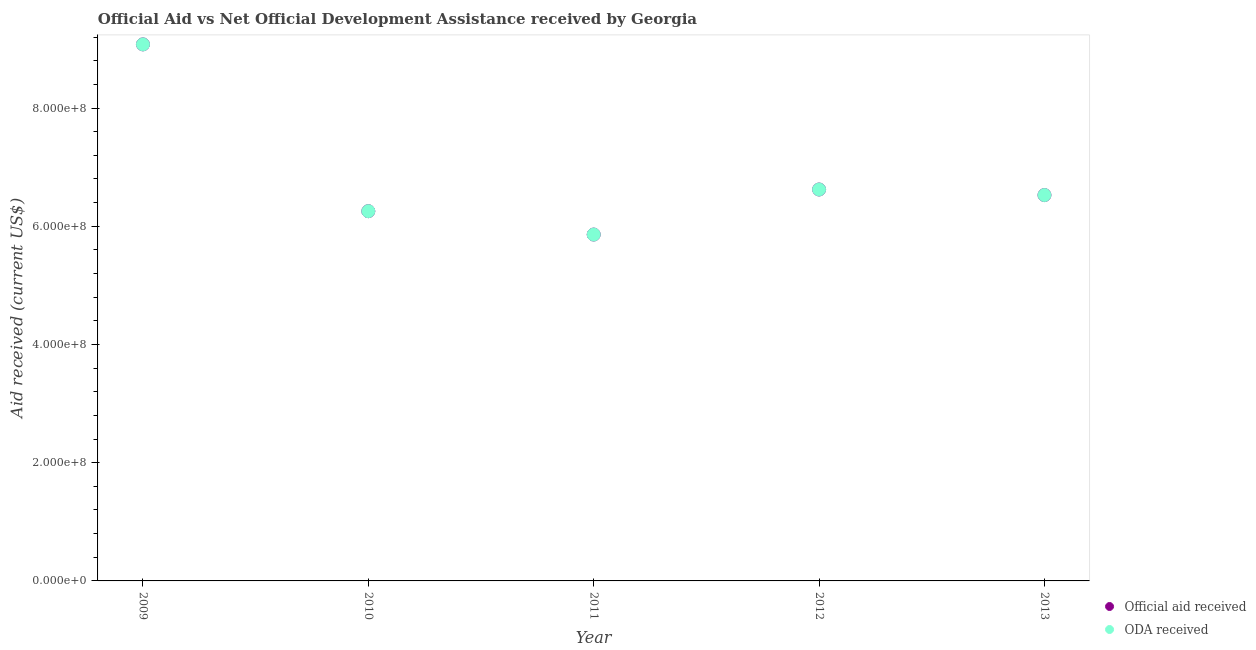How many different coloured dotlines are there?
Offer a very short reply. 2. What is the oda received in 2013?
Your response must be concise. 6.53e+08. Across all years, what is the maximum oda received?
Your answer should be very brief. 9.08e+08. Across all years, what is the minimum oda received?
Provide a succinct answer. 5.86e+08. In which year was the oda received minimum?
Give a very brief answer. 2011. What is the total oda received in the graph?
Your response must be concise. 3.43e+09. What is the difference between the official aid received in 2011 and that in 2013?
Provide a succinct answer. -6.68e+07. What is the difference between the official aid received in 2011 and the oda received in 2009?
Your answer should be compact. -3.22e+08. What is the average official aid received per year?
Offer a very short reply. 6.87e+08. In the year 2010, what is the difference between the official aid received and oda received?
Keep it short and to the point. 0. In how many years, is the oda received greater than 160000000 US$?
Keep it short and to the point. 5. What is the ratio of the official aid received in 2009 to that in 2012?
Provide a succinct answer. 1.37. What is the difference between the highest and the second highest official aid received?
Offer a terse response. 2.45e+08. What is the difference between the highest and the lowest official aid received?
Your answer should be compact. 3.22e+08. In how many years, is the oda received greater than the average oda received taken over all years?
Give a very brief answer. 1. Does the official aid received monotonically increase over the years?
Your answer should be very brief. No. Is the official aid received strictly greater than the oda received over the years?
Offer a terse response. No. How many dotlines are there?
Your answer should be very brief. 2. How many legend labels are there?
Offer a very short reply. 2. What is the title of the graph?
Your response must be concise. Official Aid vs Net Official Development Assistance received by Georgia . What is the label or title of the X-axis?
Give a very brief answer. Year. What is the label or title of the Y-axis?
Provide a succinct answer. Aid received (current US$). What is the Aid received (current US$) of Official aid received in 2009?
Offer a terse response. 9.08e+08. What is the Aid received (current US$) of ODA received in 2009?
Provide a short and direct response. 9.08e+08. What is the Aid received (current US$) in Official aid received in 2010?
Your answer should be compact. 6.26e+08. What is the Aid received (current US$) of ODA received in 2010?
Your answer should be very brief. 6.26e+08. What is the Aid received (current US$) in Official aid received in 2011?
Provide a short and direct response. 5.86e+08. What is the Aid received (current US$) in ODA received in 2011?
Provide a short and direct response. 5.86e+08. What is the Aid received (current US$) in Official aid received in 2012?
Make the answer very short. 6.62e+08. What is the Aid received (current US$) in ODA received in 2012?
Make the answer very short. 6.62e+08. What is the Aid received (current US$) of Official aid received in 2013?
Provide a succinct answer. 6.53e+08. What is the Aid received (current US$) in ODA received in 2013?
Make the answer very short. 6.53e+08. Across all years, what is the maximum Aid received (current US$) in Official aid received?
Offer a terse response. 9.08e+08. Across all years, what is the maximum Aid received (current US$) of ODA received?
Make the answer very short. 9.08e+08. Across all years, what is the minimum Aid received (current US$) in Official aid received?
Offer a very short reply. 5.86e+08. Across all years, what is the minimum Aid received (current US$) of ODA received?
Your answer should be compact. 5.86e+08. What is the total Aid received (current US$) of Official aid received in the graph?
Your answer should be compact. 3.43e+09. What is the total Aid received (current US$) in ODA received in the graph?
Keep it short and to the point. 3.43e+09. What is the difference between the Aid received (current US$) in Official aid received in 2009 and that in 2010?
Your answer should be compact. 2.82e+08. What is the difference between the Aid received (current US$) of ODA received in 2009 and that in 2010?
Ensure brevity in your answer.  2.82e+08. What is the difference between the Aid received (current US$) of Official aid received in 2009 and that in 2011?
Your answer should be very brief. 3.22e+08. What is the difference between the Aid received (current US$) in ODA received in 2009 and that in 2011?
Ensure brevity in your answer.  3.22e+08. What is the difference between the Aid received (current US$) in Official aid received in 2009 and that in 2012?
Your answer should be compact. 2.45e+08. What is the difference between the Aid received (current US$) of ODA received in 2009 and that in 2012?
Make the answer very short. 2.45e+08. What is the difference between the Aid received (current US$) of Official aid received in 2009 and that in 2013?
Keep it short and to the point. 2.55e+08. What is the difference between the Aid received (current US$) in ODA received in 2009 and that in 2013?
Ensure brevity in your answer.  2.55e+08. What is the difference between the Aid received (current US$) in Official aid received in 2010 and that in 2011?
Provide a succinct answer. 3.95e+07. What is the difference between the Aid received (current US$) of ODA received in 2010 and that in 2011?
Keep it short and to the point. 3.95e+07. What is the difference between the Aid received (current US$) in Official aid received in 2010 and that in 2012?
Keep it short and to the point. -3.67e+07. What is the difference between the Aid received (current US$) of ODA received in 2010 and that in 2012?
Provide a short and direct response. -3.67e+07. What is the difference between the Aid received (current US$) of Official aid received in 2010 and that in 2013?
Your answer should be compact. -2.73e+07. What is the difference between the Aid received (current US$) in ODA received in 2010 and that in 2013?
Keep it short and to the point. -2.73e+07. What is the difference between the Aid received (current US$) of Official aid received in 2011 and that in 2012?
Provide a succinct answer. -7.62e+07. What is the difference between the Aid received (current US$) in ODA received in 2011 and that in 2012?
Your response must be concise. -7.62e+07. What is the difference between the Aid received (current US$) in Official aid received in 2011 and that in 2013?
Keep it short and to the point. -6.68e+07. What is the difference between the Aid received (current US$) of ODA received in 2011 and that in 2013?
Your answer should be very brief. -6.68e+07. What is the difference between the Aid received (current US$) of Official aid received in 2012 and that in 2013?
Provide a short and direct response. 9.43e+06. What is the difference between the Aid received (current US$) of ODA received in 2012 and that in 2013?
Provide a succinct answer. 9.43e+06. What is the difference between the Aid received (current US$) in Official aid received in 2009 and the Aid received (current US$) in ODA received in 2010?
Make the answer very short. 2.82e+08. What is the difference between the Aid received (current US$) in Official aid received in 2009 and the Aid received (current US$) in ODA received in 2011?
Provide a short and direct response. 3.22e+08. What is the difference between the Aid received (current US$) of Official aid received in 2009 and the Aid received (current US$) of ODA received in 2012?
Provide a succinct answer. 2.45e+08. What is the difference between the Aid received (current US$) of Official aid received in 2009 and the Aid received (current US$) of ODA received in 2013?
Provide a succinct answer. 2.55e+08. What is the difference between the Aid received (current US$) in Official aid received in 2010 and the Aid received (current US$) in ODA received in 2011?
Your answer should be very brief. 3.95e+07. What is the difference between the Aid received (current US$) of Official aid received in 2010 and the Aid received (current US$) of ODA received in 2012?
Your response must be concise. -3.67e+07. What is the difference between the Aid received (current US$) in Official aid received in 2010 and the Aid received (current US$) in ODA received in 2013?
Your response must be concise. -2.73e+07. What is the difference between the Aid received (current US$) in Official aid received in 2011 and the Aid received (current US$) in ODA received in 2012?
Ensure brevity in your answer.  -7.62e+07. What is the difference between the Aid received (current US$) of Official aid received in 2011 and the Aid received (current US$) of ODA received in 2013?
Your answer should be compact. -6.68e+07. What is the difference between the Aid received (current US$) of Official aid received in 2012 and the Aid received (current US$) of ODA received in 2013?
Your answer should be very brief. 9.43e+06. What is the average Aid received (current US$) of Official aid received per year?
Provide a succinct answer. 6.87e+08. What is the average Aid received (current US$) of ODA received per year?
Make the answer very short. 6.87e+08. In the year 2010, what is the difference between the Aid received (current US$) in Official aid received and Aid received (current US$) in ODA received?
Your answer should be very brief. 0. In the year 2013, what is the difference between the Aid received (current US$) in Official aid received and Aid received (current US$) in ODA received?
Ensure brevity in your answer.  0. What is the ratio of the Aid received (current US$) of Official aid received in 2009 to that in 2010?
Your answer should be compact. 1.45. What is the ratio of the Aid received (current US$) in ODA received in 2009 to that in 2010?
Offer a very short reply. 1.45. What is the ratio of the Aid received (current US$) of Official aid received in 2009 to that in 2011?
Your answer should be compact. 1.55. What is the ratio of the Aid received (current US$) in ODA received in 2009 to that in 2011?
Provide a short and direct response. 1.55. What is the ratio of the Aid received (current US$) in Official aid received in 2009 to that in 2012?
Keep it short and to the point. 1.37. What is the ratio of the Aid received (current US$) in ODA received in 2009 to that in 2012?
Ensure brevity in your answer.  1.37. What is the ratio of the Aid received (current US$) in Official aid received in 2009 to that in 2013?
Give a very brief answer. 1.39. What is the ratio of the Aid received (current US$) of ODA received in 2009 to that in 2013?
Provide a succinct answer. 1.39. What is the ratio of the Aid received (current US$) in Official aid received in 2010 to that in 2011?
Provide a succinct answer. 1.07. What is the ratio of the Aid received (current US$) of ODA received in 2010 to that in 2011?
Provide a short and direct response. 1.07. What is the ratio of the Aid received (current US$) of Official aid received in 2010 to that in 2012?
Keep it short and to the point. 0.94. What is the ratio of the Aid received (current US$) of ODA received in 2010 to that in 2012?
Keep it short and to the point. 0.94. What is the ratio of the Aid received (current US$) of Official aid received in 2010 to that in 2013?
Your answer should be compact. 0.96. What is the ratio of the Aid received (current US$) of ODA received in 2010 to that in 2013?
Give a very brief answer. 0.96. What is the ratio of the Aid received (current US$) in Official aid received in 2011 to that in 2012?
Provide a succinct answer. 0.88. What is the ratio of the Aid received (current US$) in ODA received in 2011 to that in 2012?
Give a very brief answer. 0.88. What is the ratio of the Aid received (current US$) in Official aid received in 2011 to that in 2013?
Offer a very short reply. 0.9. What is the ratio of the Aid received (current US$) of ODA received in 2011 to that in 2013?
Your answer should be very brief. 0.9. What is the ratio of the Aid received (current US$) in Official aid received in 2012 to that in 2013?
Offer a terse response. 1.01. What is the ratio of the Aid received (current US$) in ODA received in 2012 to that in 2013?
Offer a very short reply. 1.01. What is the difference between the highest and the second highest Aid received (current US$) in Official aid received?
Provide a succinct answer. 2.45e+08. What is the difference between the highest and the second highest Aid received (current US$) of ODA received?
Ensure brevity in your answer.  2.45e+08. What is the difference between the highest and the lowest Aid received (current US$) of Official aid received?
Offer a terse response. 3.22e+08. What is the difference between the highest and the lowest Aid received (current US$) in ODA received?
Keep it short and to the point. 3.22e+08. 